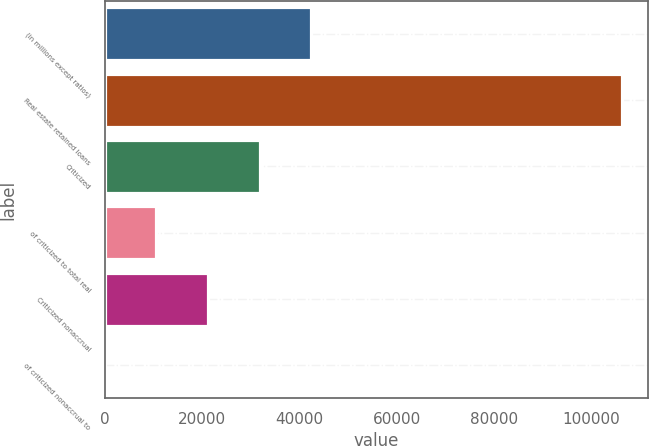<chart> <loc_0><loc_0><loc_500><loc_500><bar_chart><fcel>(in millions except ratios)<fcel>Real estate retained loans<fcel>Criticized<fcel>of criticized to total real<fcel>Criticized nonaccrual<fcel>of criticized nonaccrual to<nl><fcel>42526.1<fcel>106315<fcel>31894.6<fcel>10631.7<fcel>21263.2<fcel>0.19<nl></chart> 